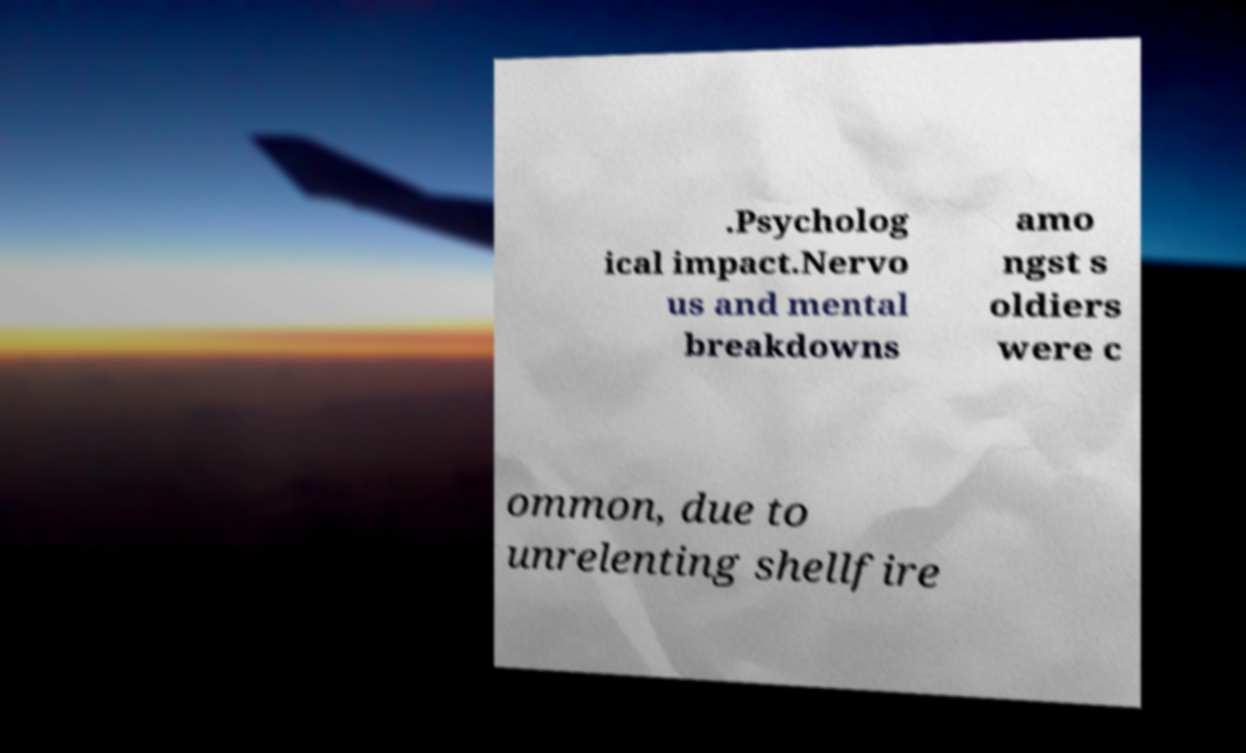Could you extract and type out the text from this image? .Psycholog ical impact.Nervo us and mental breakdowns amo ngst s oldiers were c ommon, due to unrelenting shellfire 